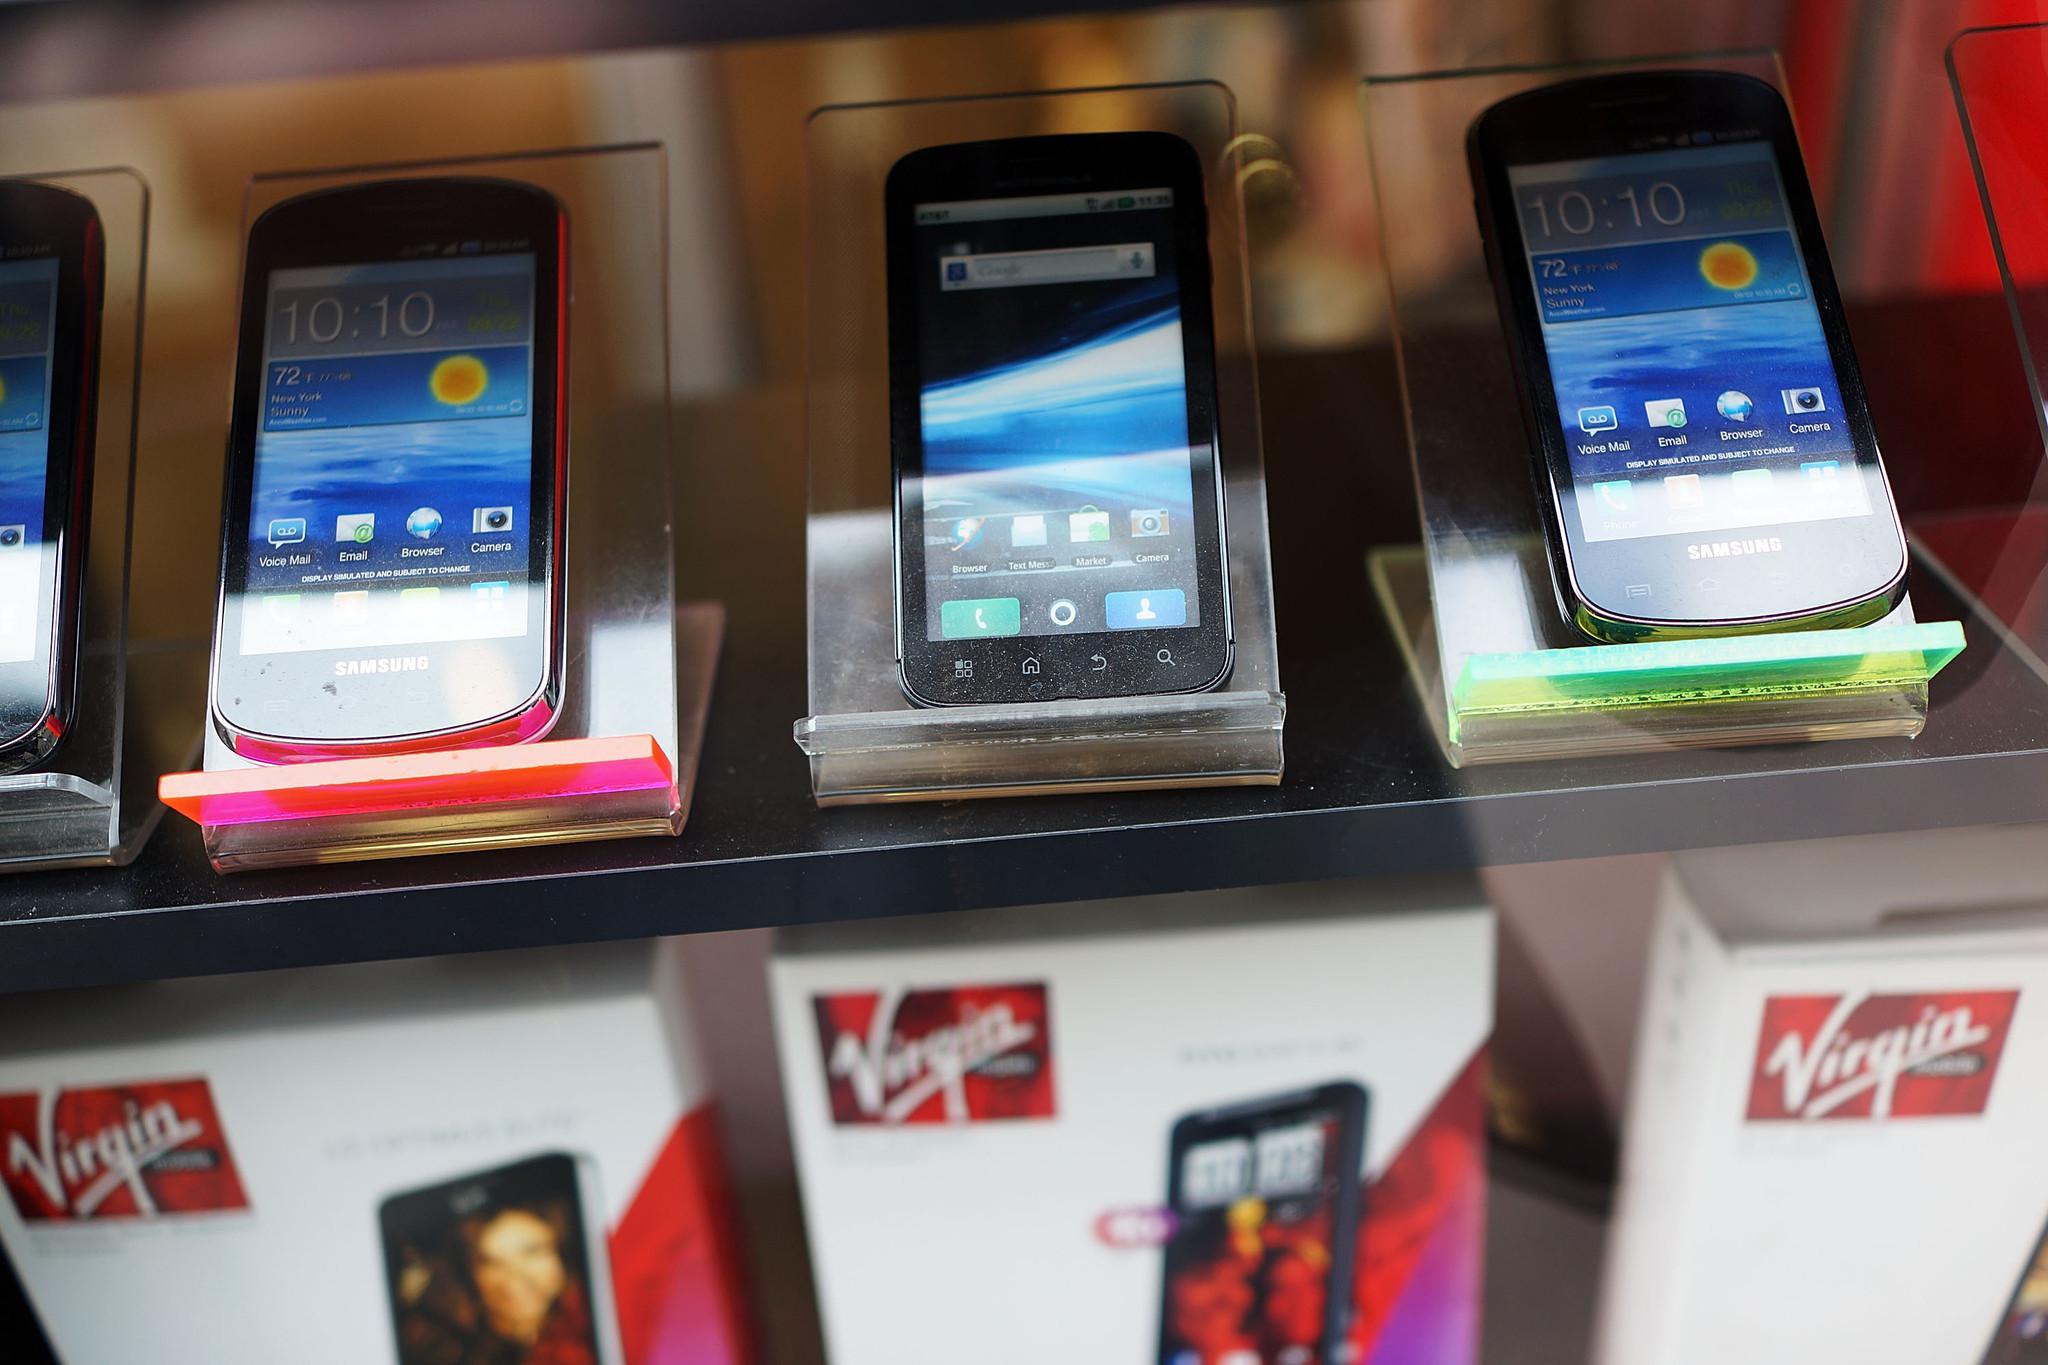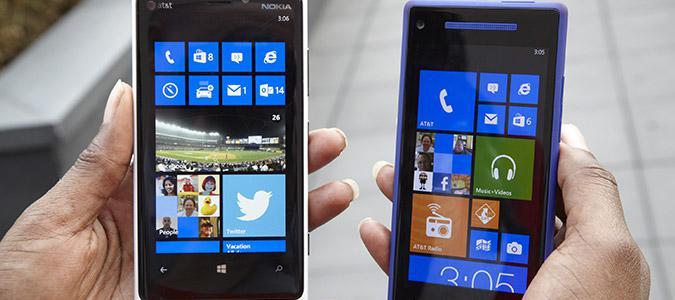The first image is the image on the left, the second image is the image on the right. Evaluate the accuracy of this statement regarding the images: "A phone is being held by a person in each photo.". Is it true? Answer yes or no. No. The first image is the image on the left, the second image is the image on the right. Given the left and right images, does the statement "The combined images include two hands, each holding a flat phone with a screen that nearly fills its front." hold true? Answer yes or no. Yes. 